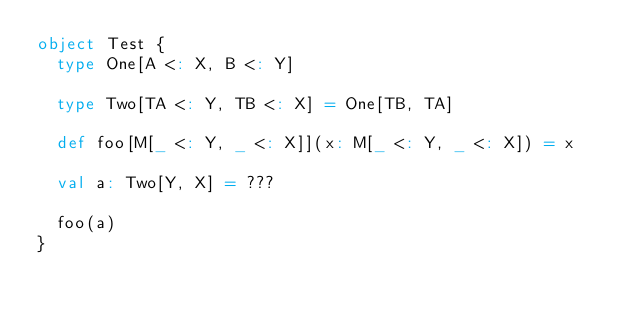Convert code to text. <code><loc_0><loc_0><loc_500><loc_500><_Scala_>object Test {
  type One[A <: X, B <: Y]

  type Two[TA <: Y, TB <: X] = One[TB, TA]

  def foo[M[_ <: Y, _ <: X]](x: M[_ <: Y, _ <: X]) = x

  val a: Two[Y, X] = ???

  foo(a)
}
</code> 